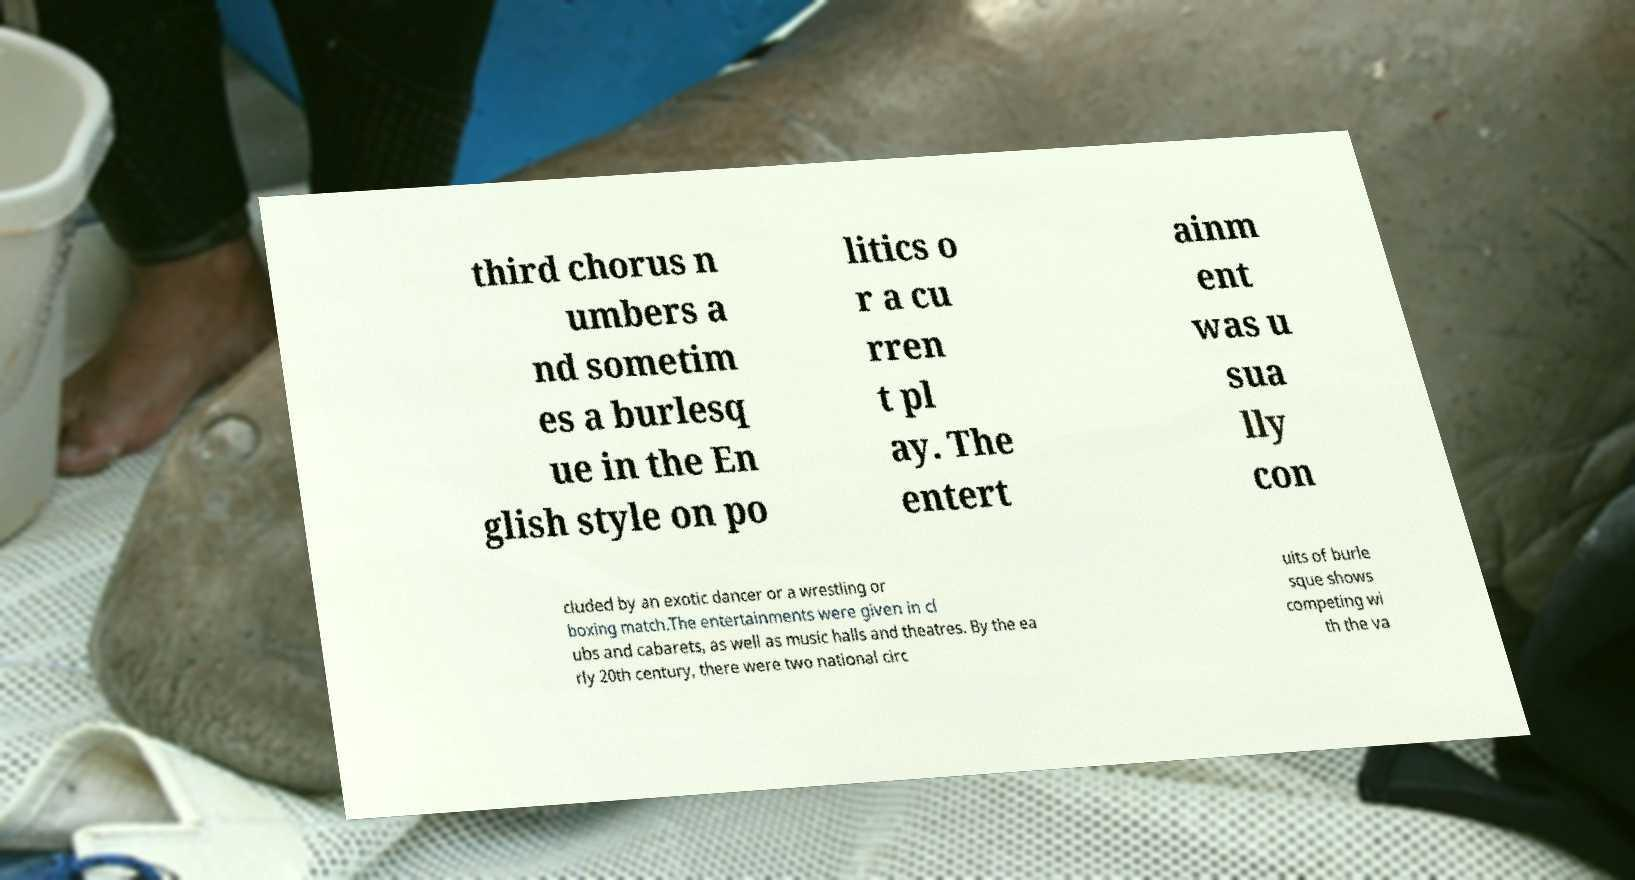For documentation purposes, I need the text within this image transcribed. Could you provide that? third chorus n umbers a nd sometim es a burlesq ue in the En glish style on po litics o r a cu rren t pl ay. The entert ainm ent was u sua lly con cluded by an exotic dancer or a wrestling or boxing match.The entertainments were given in cl ubs and cabarets, as well as music halls and theatres. By the ea rly 20th century, there were two national circ uits of burle sque shows competing wi th the va 